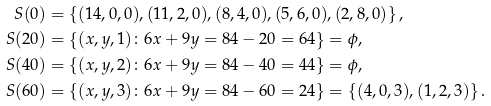<formula> <loc_0><loc_0><loc_500><loc_500>S ( 0 ) & = \left \{ ( 1 4 , 0 , 0 ) , ( 1 1 , 2 , 0 ) , ( 8 , 4 , 0 ) , ( 5 , 6 , 0 ) , ( 2 , 8 , 0 ) \right \} , \\ S ( 2 0 ) & = \left \{ ( x , y , 1 ) \colon 6 x + 9 y = 8 4 - 2 0 = 6 4 \right \} = \phi , \\ S ( 4 0 ) & = \left \{ ( x , y , 2 ) \colon 6 x + 9 y = 8 4 - 4 0 = 4 4 \right \} = \phi , \\ S ( 6 0 ) & = \left \{ ( x , y , 3 ) \colon 6 x + 9 y = 8 4 - 6 0 = 2 4 \right \} = \left \{ ( 4 , 0 , 3 ) , ( 1 , 2 , 3 ) \right \} .</formula> 